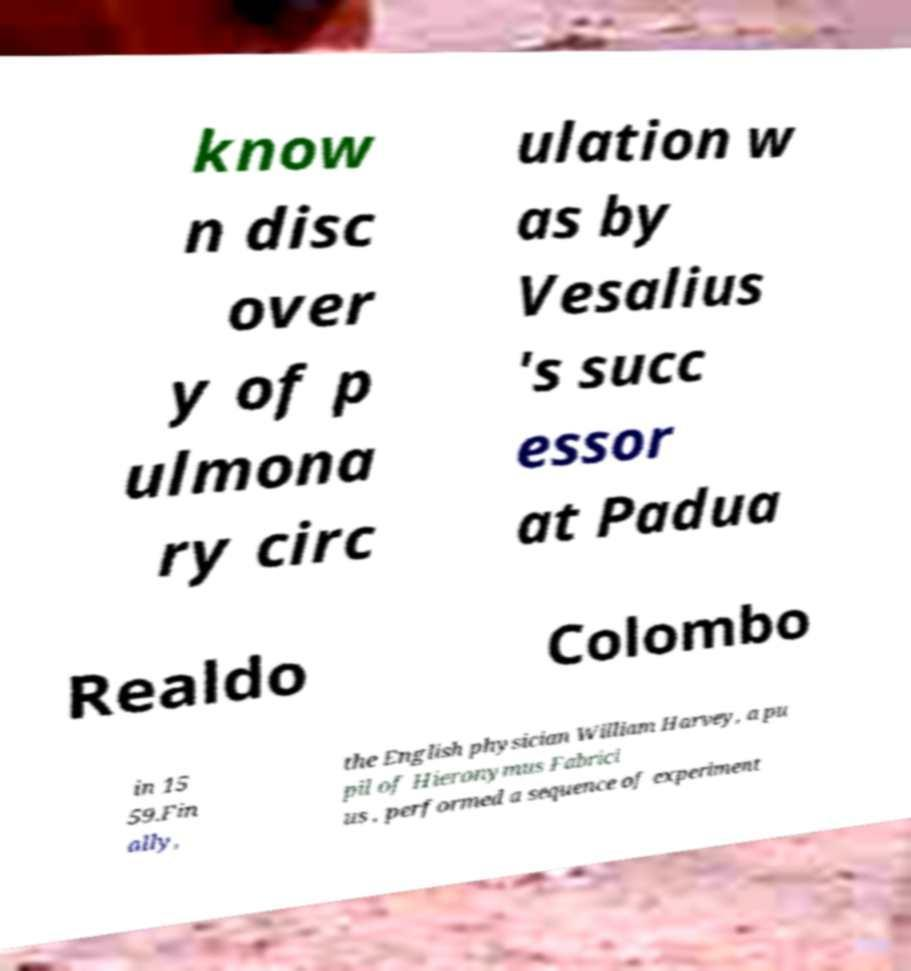Could you extract and type out the text from this image? know n disc over y of p ulmona ry circ ulation w as by Vesalius 's succ essor at Padua Realdo Colombo in 15 59.Fin ally, the English physician William Harvey, a pu pil of Hieronymus Fabrici us , performed a sequence of experiment 